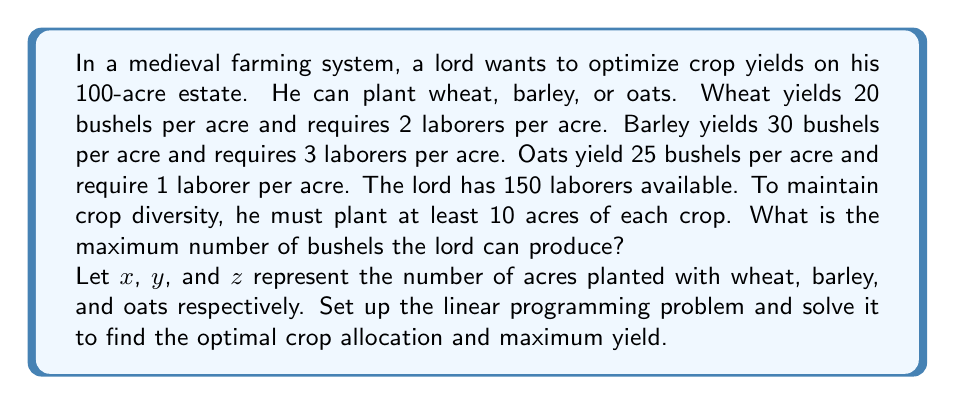Teach me how to tackle this problem. To solve this linear programming problem, we'll follow these steps:

1. Define the objective function
2. Identify the constraints
3. Set up the linear programming problem
4. Solve using the simplex method or graphical method

Step 1: Define the objective function

We want to maximize the total yield in bushels:
$$\text{Maximize } 20x + 30y + 25z$$

Step 2: Identify the constraints

- Total acreage: $x + y + z \leq 100$
- Available laborers: $2x + 3y + z \leq 150$
- Minimum acreage for each crop: $x \geq 10$, $y \geq 10$, $z \geq 10$
- Non-negativity: $x, y, z \geq 0$

Step 3: Set up the linear programming problem

$$\begin{align*}
\text{Maximize: } & 20x + 30y + 25z \\
\text{Subject to: } & x + y + z \leq 100 \\
& 2x + 3y + z \leq 150 \\
& x \geq 10 \\
& y \geq 10 \\
& z \geq 10 \\
& x, y, z \geq 0
\end{align*}$$

Step 4: Solve the problem

Using the simplex method or a linear programming solver, we find the optimal solution:

$x = 10$ (wheat)
$y = 10$ (barley)
$z = 80$ (oats)

We can verify that this solution satisfies all constraints:
- Total acreage: $10 + 10 + 80 = 100$ acres (constraint met)
- Laborers: $2(10) + 3(10) + 1(80) = 110 \leq 150$ (constraint met)
- Minimum acreage for each crop: All crops have at least 10 acres (constraints met)

The maximum yield is:
$$20(10) + 30(10) + 25(80) = 200 + 300 + 2000 = 2500 \text{ bushels}$$
Answer: The maximum number of bushels the lord can produce is 2500, achieved by planting 10 acres of wheat, 10 acres of barley, and 80 acres of oats. 